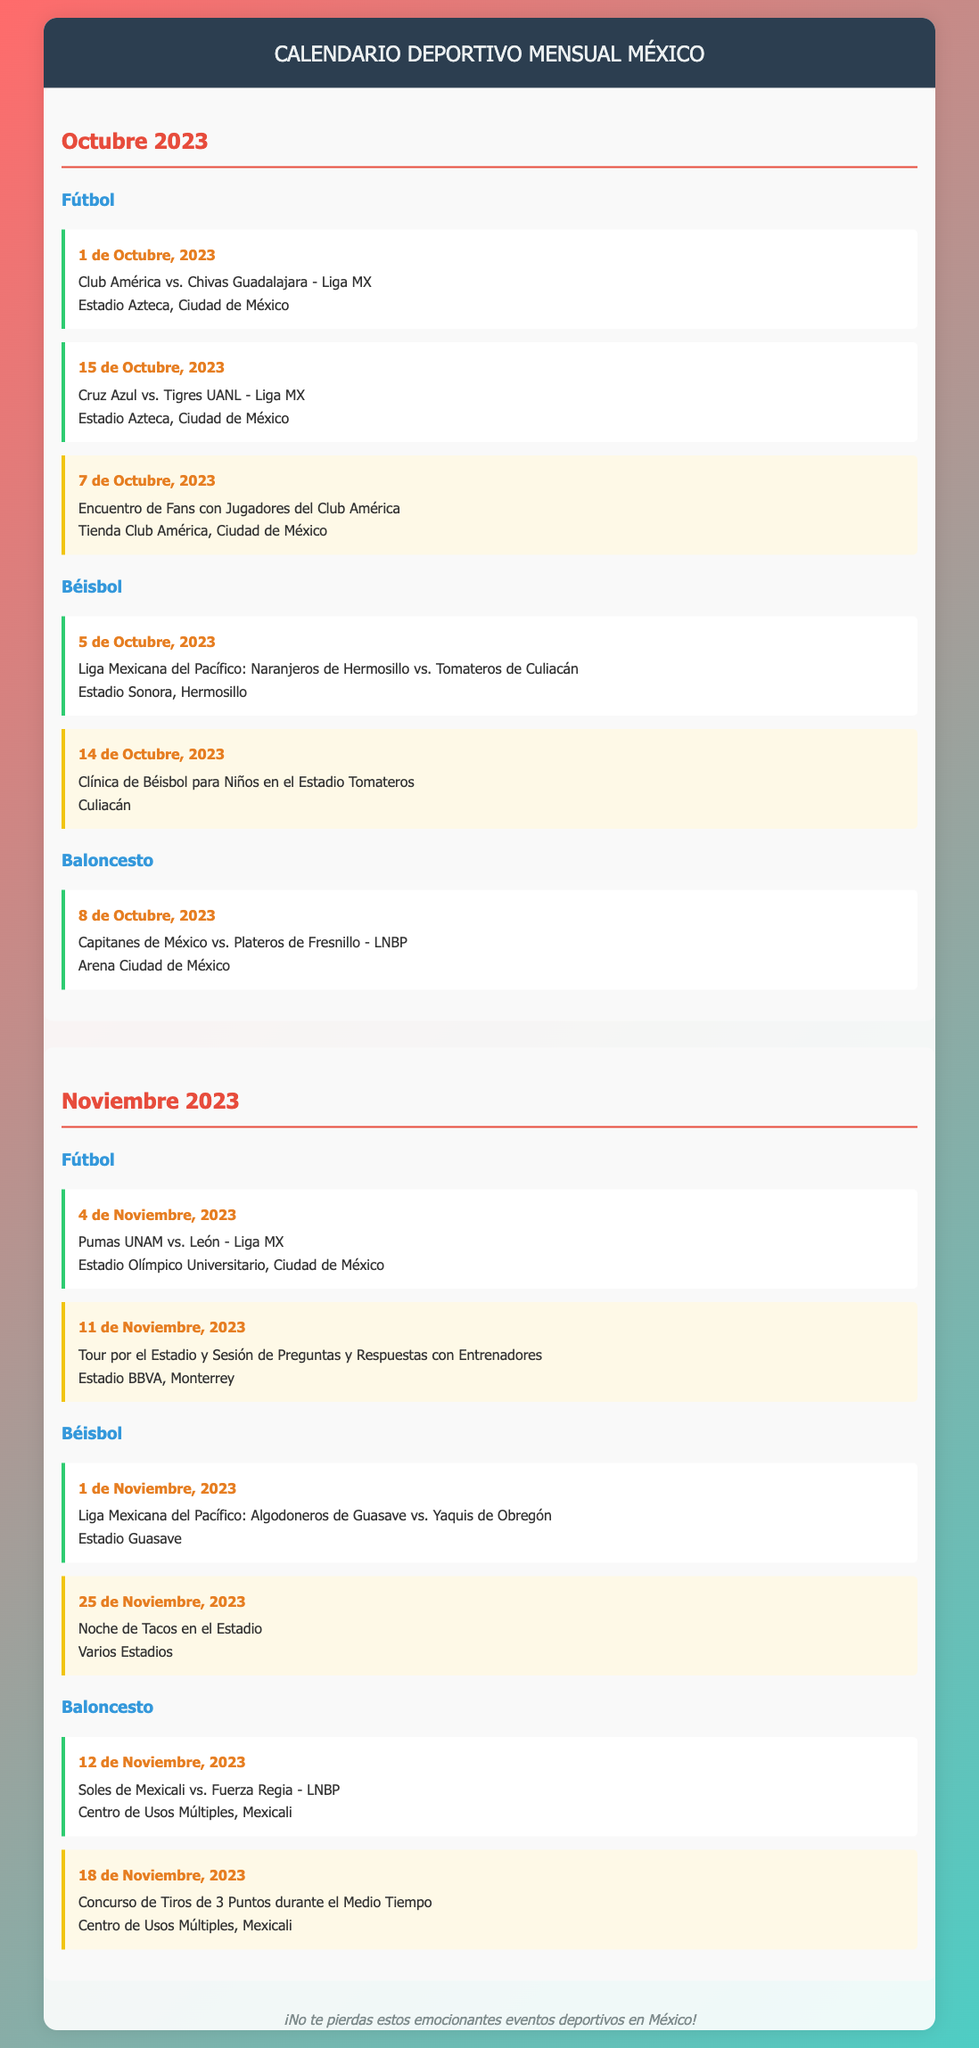What is the first football event in October 2023? The first football event listed is Club América vs. Chivas Guadalajara on October 1, 2023.
Answer: Club América vs. Chivas Guadalajara What day is the fan engagement event for football in October? The fan engagement event for football is on October 7, 2023, where fans meet players of Club América.
Answer: 7 de Octubre, 2023 Which baseball teams are playing on November 1, 2023? The matchup on November 1, 2023, is between Algodoneros de Guasave and Yaquis de Obregón.
Answer: Algodoneros de Guasave vs. Yaquis de Obregón What is the date for the "Noche de Tacos en el Estadio"? The event "Noche de Tacos en el Estadio" takes place on November 25, 2023.
Answer: 25 de Noviembre, 2023 How many basketball events are scheduled in November 2023? In November 2023, there are two basketball events: one on November 12 and one on November 18.
Answer: 2 What type of event occurs on October 14, 2023, in baseball? On October 14, 2023, there is a baseball clinic for children hosted at Estadio Tomateros.
Answer: Clínica de Béisbol para Niños Which month features a fan engagement tour at Estadio BBVA? The fan engagement tour at Estadio BBVA is scheduled for November 11, 2023.
Answer: Noviembre 2023 What sport is featured on October 8, 2023? The sport featured on October 8, 2023, is basketball, with a game between Capitanes de México and Plateros de Fresnillo.
Answer: Baloncesto 